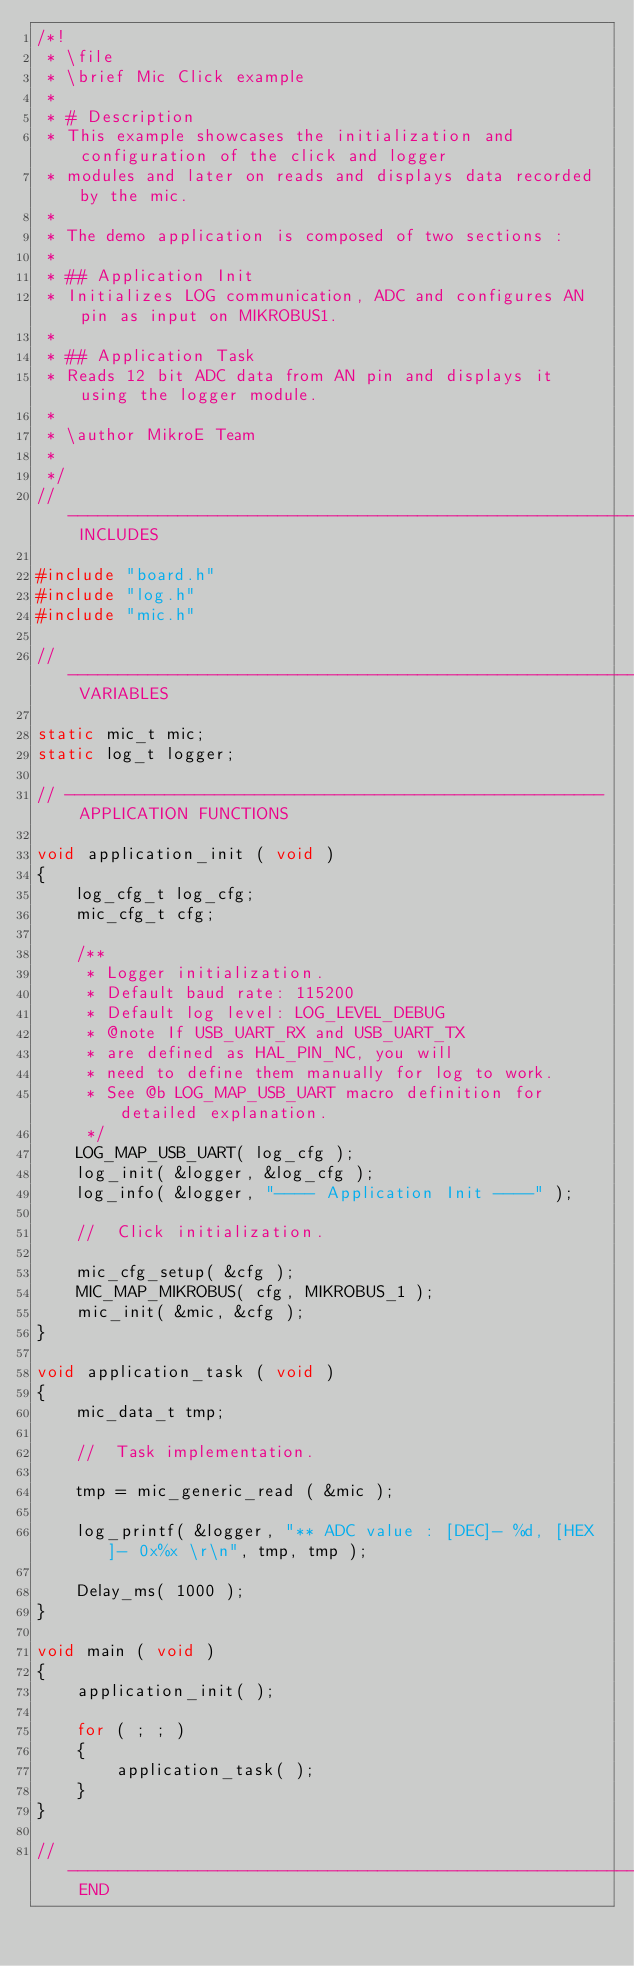Convert code to text. <code><loc_0><loc_0><loc_500><loc_500><_C_>/*!
 * \file 
 * \brief Mic Click example
 * 
 * # Description
 * This example showcases the initialization and configuration of the click and logger
 * modules and later on reads and displays data recorded by the mic.
 *
 * The demo application is composed of two sections :
 * 
 * ## Application Init 
 * Initializes LOG communication, ADC and configures AN pin as input on MIKROBUS1.
 * 
 * ## Application Task  
 * Reads 12 bit ADC data from AN pin and displays it using the logger module.
 * 
 * \author MikroE Team
 *
 */
// ------------------------------------------------------------------- INCLUDES

#include "board.h"
#include "log.h"
#include "mic.h"

// ------------------------------------------------------------------ VARIABLES

static mic_t mic;
static log_t logger;

// ------------------------------------------------------ APPLICATION FUNCTIONS

void application_init ( void )
{
    log_cfg_t log_cfg;
    mic_cfg_t cfg;

    /** 
     * Logger initialization.
     * Default baud rate: 115200
     * Default log level: LOG_LEVEL_DEBUG
     * @note If USB_UART_RX and USB_UART_TX 
     * are defined as HAL_PIN_NC, you will 
     * need to define them manually for log to work. 
     * See @b LOG_MAP_USB_UART macro definition for detailed explanation.
     */
    LOG_MAP_USB_UART( log_cfg );
    log_init( &logger, &log_cfg );
    log_info( &logger, "---- Application Init ----" );

    //  Click initialization.

    mic_cfg_setup( &cfg );
    MIC_MAP_MIKROBUS( cfg, MIKROBUS_1 );
    mic_init( &mic, &cfg );
}

void application_task ( void )
{
    mic_data_t tmp;
    
    //  Task implementation.
    
    tmp = mic_generic_read ( &mic );

    log_printf( &logger, "** ADC value : [DEC]- %d, [HEX]- 0x%x \r\n", tmp, tmp );

    Delay_ms( 1000 );
}

void main ( void )
{
    application_init( );

    for ( ; ; )
    {
        application_task( );
    }
}

// ------------------------------------------------------------------------ END
</code> 